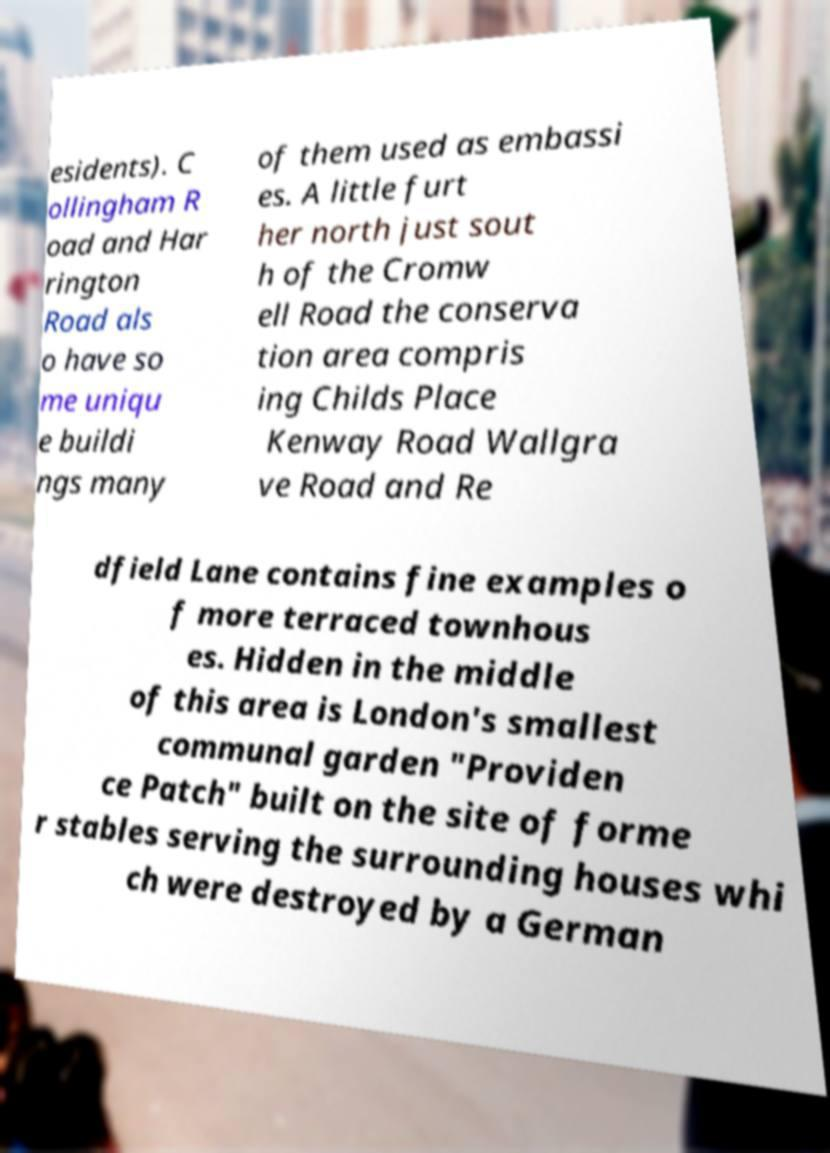Can you accurately transcribe the text from the provided image for me? esidents). C ollingham R oad and Har rington Road als o have so me uniqu e buildi ngs many of them used as embassi es. A little furt her north just sout h of the Cromw ell Road the conserva tion area compris ing Childs Place Kenway Road Wallgra ve Road and Re dfield Lane contains fine examples o f more terraced townhous es. Hidden in the middle of this area is London's smallest communal garden "Providen ce Patch" built on the site of forme r stables serving the surrounding houses whi ch were destroyed by a German 